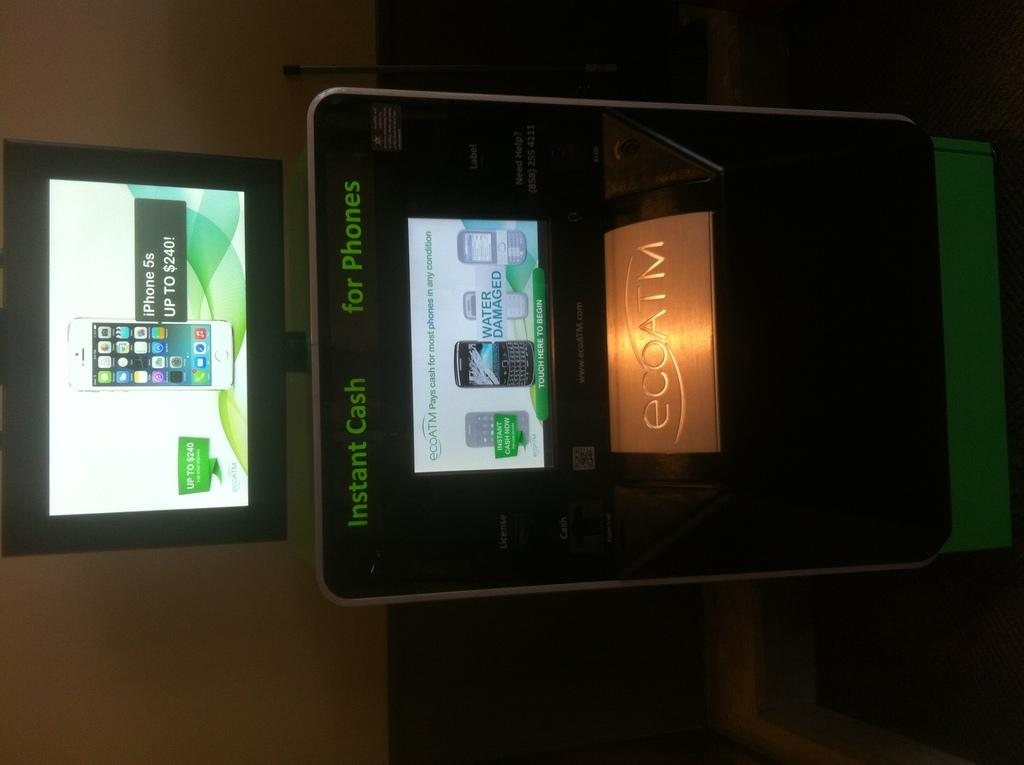Provide a one-sentence caption for the provided image. An eco ATM advertises instant cash for phones, offering up to $240 for an iPhone 5s. 